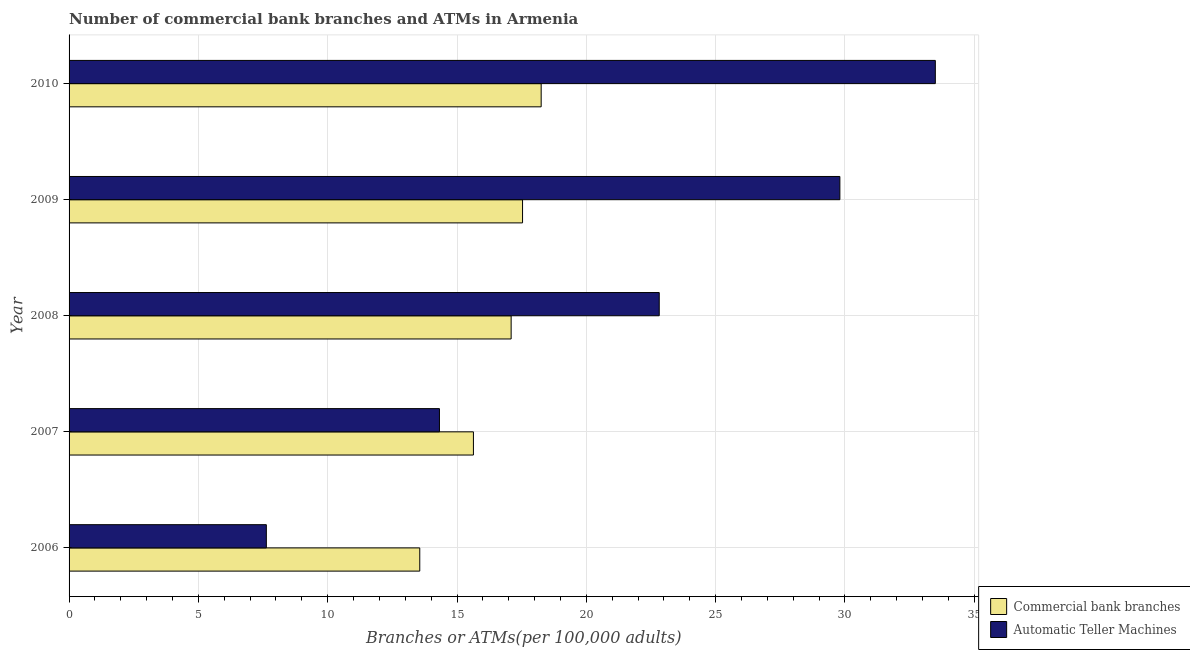How many different coloured bars are there?
Keep it short and to the point. 2. How many groups of bars are there?
Your answer should be compact. 5. Are the number of bars on each tick of the Y-axis equal?
Make the answer very short. Yes. How many bars are there on the 1st tick from the top?
Offer a terse response. 2. What is the label of the 4th group of bars from the top?
Your answer should be very brief. 2007. What is the number of atms in 2009?
Ensure brevity in your answer.  29.81. Across all years, what is the maximum number of atms?
Ensure brevity in your answer.  33.5. Across all years, what is the minimum number of atms?
Offer a terse response. 7.63. What is the total number of atms in the graph?
Ensure brevity in your answer.  108.07. What is the difference between the number of atms in 2007 and that in 2008?
Provide a short and direct response. -8.5. What is the difference between the number of atms in 2010 and the number of commercal bank branches in 2007?
Your answer should be compact. 17.86. What is the average number of commercal bank branches per year?
Provide a short and direct response. 16.42. In the year 2010, what is the difference between the number of commercal bank branches and number of atms?
Give a very brief answer. -15.24. In how many years, is the number of commercal bank branches greater than 1 ?
Your answer should be very brief. 5. What is the ratio of the number of atms in 2007 to that in 2008?
Your answer should be compact. 0.63. Is the difference between the number of atms in 2006 and 2008 greater than the difference between the number of commercal bank branches in 2006 and 2008?
Keep it short and to the point. No. What is the difference between the highest and the second highest number of commercal bank branches?
Your answer should be very brief. 0.72. What is the difference between the highest and the lowest number of atms?
Your answer should be compact. 25.87. What does the 1st bar from the top in 2008 represents?
Your answer should be compact. Automatic Teller Machines. What does the 1st bar from the bottom in 2010 represents?
Provide a succinct answer. Commercial bank branches. Are all the bars in the graph horizontal?
Your answer should be compact. Yes. How many years are there in the graph?
Provide a short and direct response. 5. What is the difference between two consecutive major ticks on the X-axis?
Give a very brief answer. 5. Does the graph contain any zero values?
Ensure brevity in your answer.  No. Does the graph contain grids?
Your response must be concise. Yes. Where does the legend appear in the graph?
Give a very brief answer. Bottom right. How many legend labels are there?
Your response must be concise. 2. How are the legend labels stacked?
Ensure brevity in your answer.  Vertical. What is the title of the graph?
Provide a short and direct response. Number of commercial bank branches and ATMs in Armenia. What is the label or title of the X-axis?
Give a very brief answer. Branches or ATMs(per 100,0 adults). What is the label or title of the Y-axis?
Your response must be concise. Year. What is the Branches or ATMs(per 100,000 adults) in Commercial bank branches in 2006?
Your answer should be very brief. 13.56. What is the Branches or ATMs(per 100,000 adults) of Automatic Teller Machines in 2006?
Provide a short and direct response. 7.63. What is the Branches or ATMs(per 100,000 adults) of Commercial bank branches in 2007?
Offer a terse response. 15.63. What is the Branches or ATMs(per 100,000 adults) in Automatic Teller Machines in 2007?
Keep it short and to the point. 14.32. What is the Branches or ATMs(per 100,000 adults) of Commercial bank branches in 2008?
Make the answer very short. 17.09. What is the Branches or ATMs(per 100,000 adults) of Automatic Teller Machines in 2008?
Provide a succinct answer. 22.82. What is the Branches or ATMs(per 100,000 adults) in Commercial bank branches in 2009?
Your answer should be very brief. 17.53. What is the Branches or ATMs(per 100,000 adults) of Automatic Teller Machines in 2009?
Offer a very short reply. 29.81. What is the Branches or ATMs(per 100,000 adults) of Commercial bank branches in 2010?
Make the answer very short. 18.25. What is the Branches or ATMs(per 100,000 adults) in Automatic Teller Machines in 2010?
Ensure brevity in your answer.  33.5. Across all years, what is the maximum Branches or ATMs(per 100,000 adults) in Commercial bank branches?
Offer a terse response. 18.25. Across all years, what is the maximum Branches or ATMs(per 100,000 adults) in Automatic Teller Machines?
Keep it short and to the point. 33.5. Across all years, what is the minimum Branches or ATMs(per 100,000 adults) of Commercial bank branches?
Give a very brief answer. 13.56. Across all years, what is the minimum Branches or ATMs(per 100,000 adults) of Automatic Teller Machines?
Your answer should be very brief. 7.63. What is the total Branches or ATMs(per 100,000 adults) in Commercial bank branches in the graph?
Provide a succinct answer. 82.08. What is the total Branches or ATMs(per 100,000 adults) in Automatic Teller Machines in the graph?
Keep it short and to the point. 108.07. What is the difference between the Branches or ATMs(per 100,000 adults) in Commercial bank branches in 2006 and that in 2007?
Your answer should be very brief. -2.07. What is the difference between the Branches or ATMs(per 100,000 adults) in Automatic Teller Machines in 2006 and that in 2007?
Keep it short and to the point. -6.69. What is the difference between the Branches or ATMs(per 100,000 adults) of Commercial bank branches in 2006 and that in 2008?
Offer a very short reply. -3.53. What is the difference between the Branches or ATMs(per 100,000 adults) of Automatic Teller Machines in 2006 and that in 2008?
Provide a short and direct response. -15.19. What is the difference between the Branches or ATMs(per 100,000 adults) of Commercial bank branches in 2006 and that in 2009?
Provide a short and direct response. -3.97. What is the difference between the Branches or ATMs(per 100,000 adults) of Automatic Teller Machines in 2006 and that in 2009?
Provide a succinct answer. -22.18. What is the difference between the Branches or ATMs(per 100,000 adults) of Commercial bank branches in 2006 and that in 2010?
Offer a terse response. -4.69. What is the difference between the Branches or ATMs(per 100,000 adults) in Automatic Teller Machines in 2006 and that in 2010?
Give a very brief answer. -25.87. What is the difference between the Branches or ATMs(per 100,000 adults) of Commercial bank branches in 2007 and that in 2008?
Your answer should be very brief. -1.46. What is the difference between the Branches or ATMs(per 100,000 adults) of Automatic Teller Machines in 2007 and that in 2008?
Your answer should be very brief. -8.5. What is the difference between the Branches or ATMs(per 100,000 adults) in Commercial bank branches in 2007 and that in 2009?
Give a very brief answer. -1.9. What is the difference between the Branches or ATMs(per 100,000 adults) in Automatic Teller Machines in 2007 and that in 2009?
Your answer should be very brief. -15.48. What is the difference between the Branches or ATMs(per 100,000 adults) in Commercial bank branches in 2007 and that in 2010?
Keep it short and to the point. -2.62. What is the difference between the Branches or ATMs(per 100,000 adults) in Automatic Teller Machines in 2007 and that in 2010?
Give a very brief answer. -19.17. What is the difference between the Branches or ATMs(per 100,000 adults) in Commercial bank branches in 2008 and that in 2009?
Your response must be concise. -0.44. What is the difference between the Branches or ATMs(per 100,000 adults) of Automatic Teller Machines in 2008 and that in 2009?
Provide a short and direct response. -6.98. What is the difference between the Branches or ATMs(per 100,000 adults) of Commercial bank branches in 2008 and that in 2010?
Your answer should be compact. -1.16. What is the difference between the Branches or ATMs(per 100,000 adults) in Automatic Teller Machines in 2008 and that in 2010?
Your answer should be very brief. -10.68. What is the difference between the Branches or ATMs(per 100,000 adults) of Commercial bank branches in 2009 and that in 2010?
Give a very brief answer. -0.72. What is the difference between the Branches or ATMs(per 100,000 adults) of Automatic Teller Machines in 2009 and that in 2010?
Make the answer very short. -3.69. What is the difference between the Branches or ATMs(per 100,000 adults) of Commercial bank branches in 2006 and the Branches or ATMs(per 100,000 adults) of Automatic Teller Machines in 2007?
Offer a very short reply. -0.76. What is the difference between the Branches or ATMs(per 100,000 adults) in Commercial bank branches in 2006 and the Branches or ATMs(per 100,000 adults) in Automatic Teller Machines in 2008?
Your response must be concise. -9.26. What is the difference between the Branches or ATMs(per 100,000 adults) in Commercial bank branches in 2006 and the Branches or ATMs(per 100,000 adults) in Automatic Teller Machines in 2009?
Provide a succinct answer. -16.24. What is the difference between the Branches or ATMs(per 100,000 adults) in Commercial bank branches in 2006 and the Branches or ATMs(per 100,000 adults) in Automatic Teller Machines in 2010?
Your response must be concise. -19.93. What is the difference between the Branches or ATMs(per 100,000 adults) of Commercial bank branches in 2007 and the Branches or ATMs(per 100,000 adults) of Automatic Teller Machines in 2008?
Provide a succinct answer. -7.19. What is the difference between the Branches or ATMs(per 100,000 adults) of Commercial bank branches in 2007 and the Branches or ATMs(per 100,000 adults) of Automatic Teller Machines in 2009?
Your answer should be compact. -14.17. What is the difference between the Branches or ATMs(per 100,000 adults) of Commercial bank branches in 2007 and the Branches or ATMs(per 100,000 adults) of Automatic Teller Machines in 2010?
Give a very brief answer. -17.86. What is the difference between the Branches or ATMs(per 100,000 adults) of Commercial bank branches in 2008 and the Branches or ATMs(per 100,000 adults) of Automatic Teller Machines in 2009?
Your answer should be very brief. -12.71. What is the difference between the Branches or ATMs(per 100,000 adults) of Commercial bank branches in 2008 and the Branches or ATMs(per 100,000 adults) of Automatic Teller Machines in 2010?
Give a very brief answer. -16.4. What is the difference between the Branches or ATMs(per 100,000 adults) in Commercial bank branches in 2009 and the Branches or ATMs(per 100,000 adults) in Automatic Teller Machines in 2010?
Offer a terse response. -15.96. What is the average Branches or ATMs(per 100,000 adults) in Commercial bank branches per year?
Keep it short and to the point. 16.42. What is the average Branches or ATMs(per 100,000 adults) in Automatic Teller Machines per year?
Give a very brief answer. 21.61. In the year 2006, what is the difference between the Branches or ATMs(per 100,000 adults) in Commercial bank branches and Branches or ATMs(per 100,000 adults) in Automatic Teller Machines?
Give a very brief answer. 5.93. In the year 2007, what is the difference between the Branches or ATMs(per 100,000 adults) in Commercial bank branches and Branches or ATMs(per 100,000 adults) in Automatic Teller Machines?
Provide a short and direct response. 1.31. In the year 2008, what is the difference between the Branches or ATMs(per 100,000 adults) of Commercial bank branches and Branches or ATMs(per 100,000 adults) of Automatic Teller Machines?
Keep it short and to the point. -5.73. In the year 2009, what is the difference between the Branches or ATMs(per 100,000 adults) in Commercial bank branches and Branches or ATMs(per 100,000 adults) in Automatic Teller Machines?
Provide a succinct answer. -12.27. In the year 2010, what is the difference between the Branches or ATMs(per 100,000 adults) in Commercial bank branches and Branches or ATMs(per 100,000 adults) in Automatic Teller Machines?
Offer a very short reply. -15.24. What is the ratio of the Branches or ATMs(per 100,000 adults) in Commercial bank branches in 2006 to that in 2007?
Ensure brevity in your answer.  0.87. What is the ratio of the Branches or ATMs(per 100,000 adults) in Automatic Teller Machines in 2006 to that in 2007?
Offer a very short reply. 0.53. What is the ratio of the Branches or ATMs(per 100,000 adults) of Commercial bank branches in 2006 to that in 2008?
Your response must be concise. 0.79. What is the ratio of the Branches or ATMs(per 100,000 adults) in Automatic Teller Machines in 2006 to that in 2008?
Offer a terse response. 0.33. What is the ratio of the Branches or ATMs(per 100,000 adults) of Commercial bank branches in 2006 to that in 2009?
Your answer should be very brief. 0.77. What is the ratio of the Branches or ATMs(per 100,000 adults) of Automatic Teller Machines in 2006 to that in 2009?
Your answer should be compact. 0.26. What is the ratio of the Branches or ATMs(per 100,000 adults) in Commercial bank branches in 2006 to that in 2010?
Ensure brevity in your answer.  0.74. What is the ratio of the Branches or ATMs(per 100,000 adults) of Automatic Teller Machines in 2006 to that in 2010?
Make the answer very short. 0.23. What is the ratio of the Branches or ATMs(per 100,000 adults) in Commercial bank branches in 2007 to that in 2008?
Your answer should be very brief. 0.91. What is the ratio of the Branches or ATMs(per 100,000 adults) of Automatic Teller Machines in 2007 to that in 2008?
Your response must be concise. 0.63. What is the ratio of the Branches or ATMs(per 100,000 adults) of Commercial bank branches in 2007 to that in 2009?
Make the answer very short. 0.89. What is the ratio of the Branches or ATMs(per 100,000 adults) of Automatic Teller Machines in 2007 to that in 2009?
Ensure brevity in your answer.  0.48. What is the ratio of the Branches or ATMs(per 100,000 adults) of Commercial bank branches in 2007 to that in 2010?
Your response must be concise. 0.86. What is the ratio of the Branches or ATMs(per 100,000 adults) of Automatic Teller Machines in 2007 to that in 2010?
Make the answer very short. 0.43. What is the ratio of the Branches or ATMs(per 100,000 adults) of Commercial bank branches in 2008 to that in 2009?
Provide a short and direct response. 0.97. What is the ratio of the Branches or ATMs(per 100,000 adults) in Automatic Teller Machines in 2008 to that in 2009?
Provide a succinct answer. 0.77. What is the ratio of the Branches or ATMs(per 100,000 adults) in Commercial bank branches in 2008 to that in 2010?
Your response must be concise. 0.94. What is the ratio of the Branches or ATMs(per 100,000 adults) of Automatic Teller Machines in 2008 to that in 2010?
Your response must be concise. 0.68. What is the ratio of the Branches or ATMs(per 100,000 adults) of Commercial bank branches in 2009 to that in 2010?
Offer a very short reply. 0.96. What is the ratio of the Branches or ATMs(per 100,000 adults) of Automatic Teller Machines in 2009 to that in 2010?
Your response must be concise. 0.89. What is the difference between the highest and the second highest Branches or ATMs(per 100,000 adults) in Commercial bank branches?
Offer a very short reply. 0.72. What is the difference between the highest and the second highest Branches or ATMs(per 100,000 adults) of Automatic Teller Machines?
Your answer should be compact. 3.69. What is the difference between the highest and the lowest Branches or ATMs(per 100,000 adults) of Commercial bank branches?
Provide a succinct answer. 4.69. What is the difference between the highest and the lowest Branches or ATMs(per 100,000 adults) in Automatic Teller Machines?
Your answer should be very brief. 25.87. 